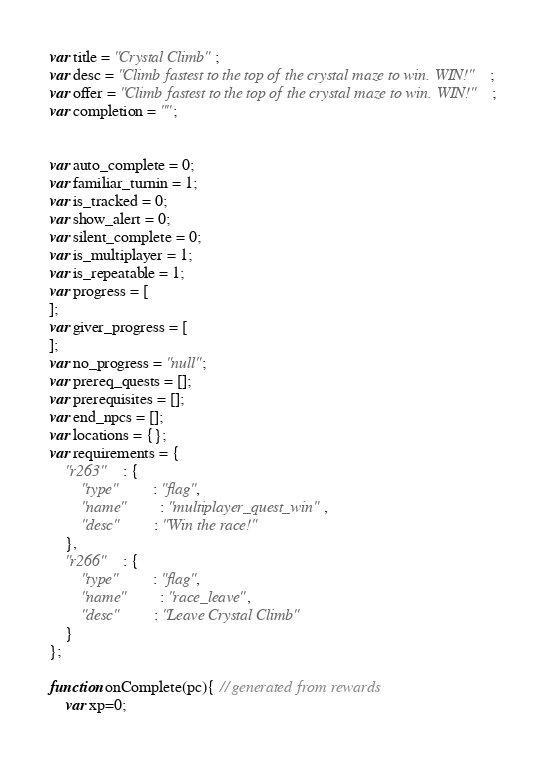<code> <loc_0><loc_0><loc_500><loc_500><_JavaScript_>var title = "Crystal Climb";
var desc = "Climb fastest to the top of the crystal maze to win. WIN!";
var offer = "Climb fastest to the top of the crystal maze to win. WIN!";
var completion = "";


var auto_complete = 0;
var familiar_turnin = 1;
var is_tracked = 0;
var show_alert = 0;
var silent_complete = 0;
var is_multiplayer = 1;
var is_repeatable = 1;
var progress = [
];
var giver_progress = [
];
var no_progress = "null";
var prereq_quests = [];
var prerequisites = [];
var end_npcs = [];
var locations = {};
var requirements = {
	"r263"	: {
		"type"		: "flag",
		"name"		: "multiplayer_quest_win",
		"desc"		: "Win the race!"
	},
	"r266"	: {
		"type"		: "flag",
		"name"		: "race_leave",
		"desc"		: "Leave Crystal Climb"
	}
};

function onComplete(pc){ // generated from rewards
	var xp=0;</code> 